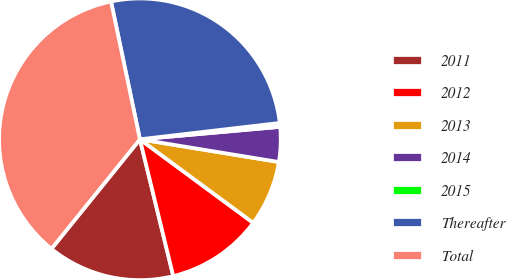Convert chart to OTSL. <chart><loc_0><loc_0><loc_500><loc_500><pie_chart><fcel>2011<fcel>2012<fcel>2013<fcel>2014<fcel>2015<fcel>Thereafter<fcel>Total<nl><fcel>14.62%<fcel>11.08%<fcel>7.53%<fcel>3.99%<fcel>0.44%<fcel>26.43%<fcel>35.89%<nl></chart> 